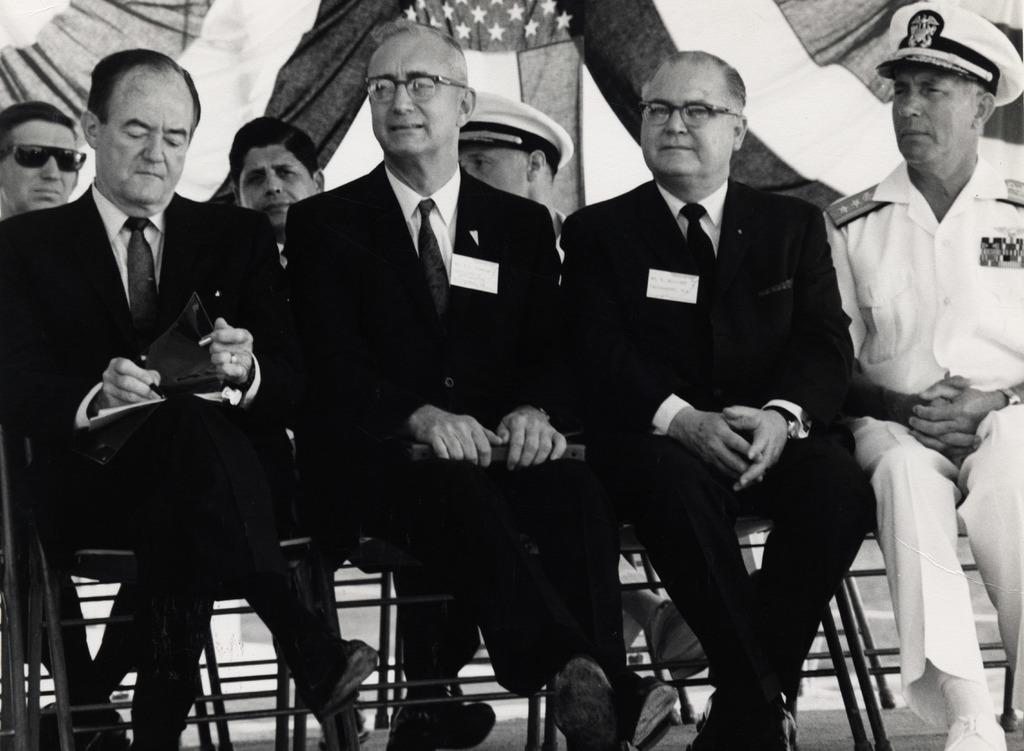How would you summarize this image in a sentence or two? This is a black and white image. We can see a group of people sitting on the chairs. On the left side of the image, a person holding a pen and an object. Behind the people, those are looking like clothes. 